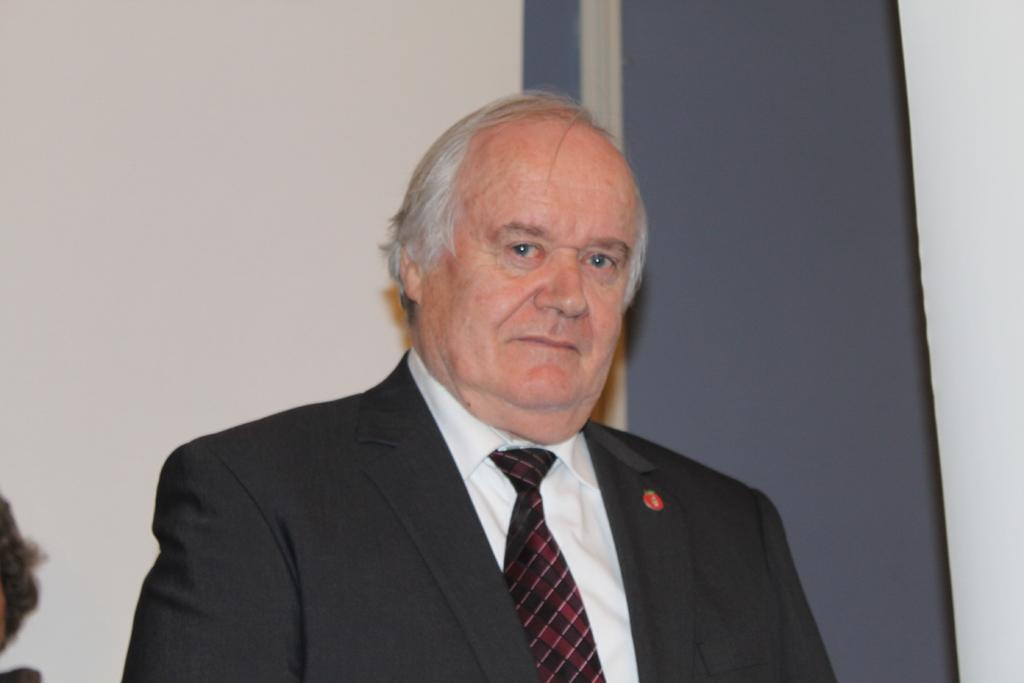Who is the main subject in the foreground of the image? There is a man in the foreground of the image. What can be seen in the background of the image? There is a wall in the background of the image. How many frogs are sitting on the man's head in the image? There are no frogs present in the image, so it is not possible to determine how many might be sitting on the man's head. 